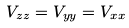<formula> <loc_0><loc_0><loc_500><loc_500>V _ { z z } = V _ { y y } = V _ { x x }</formula> 